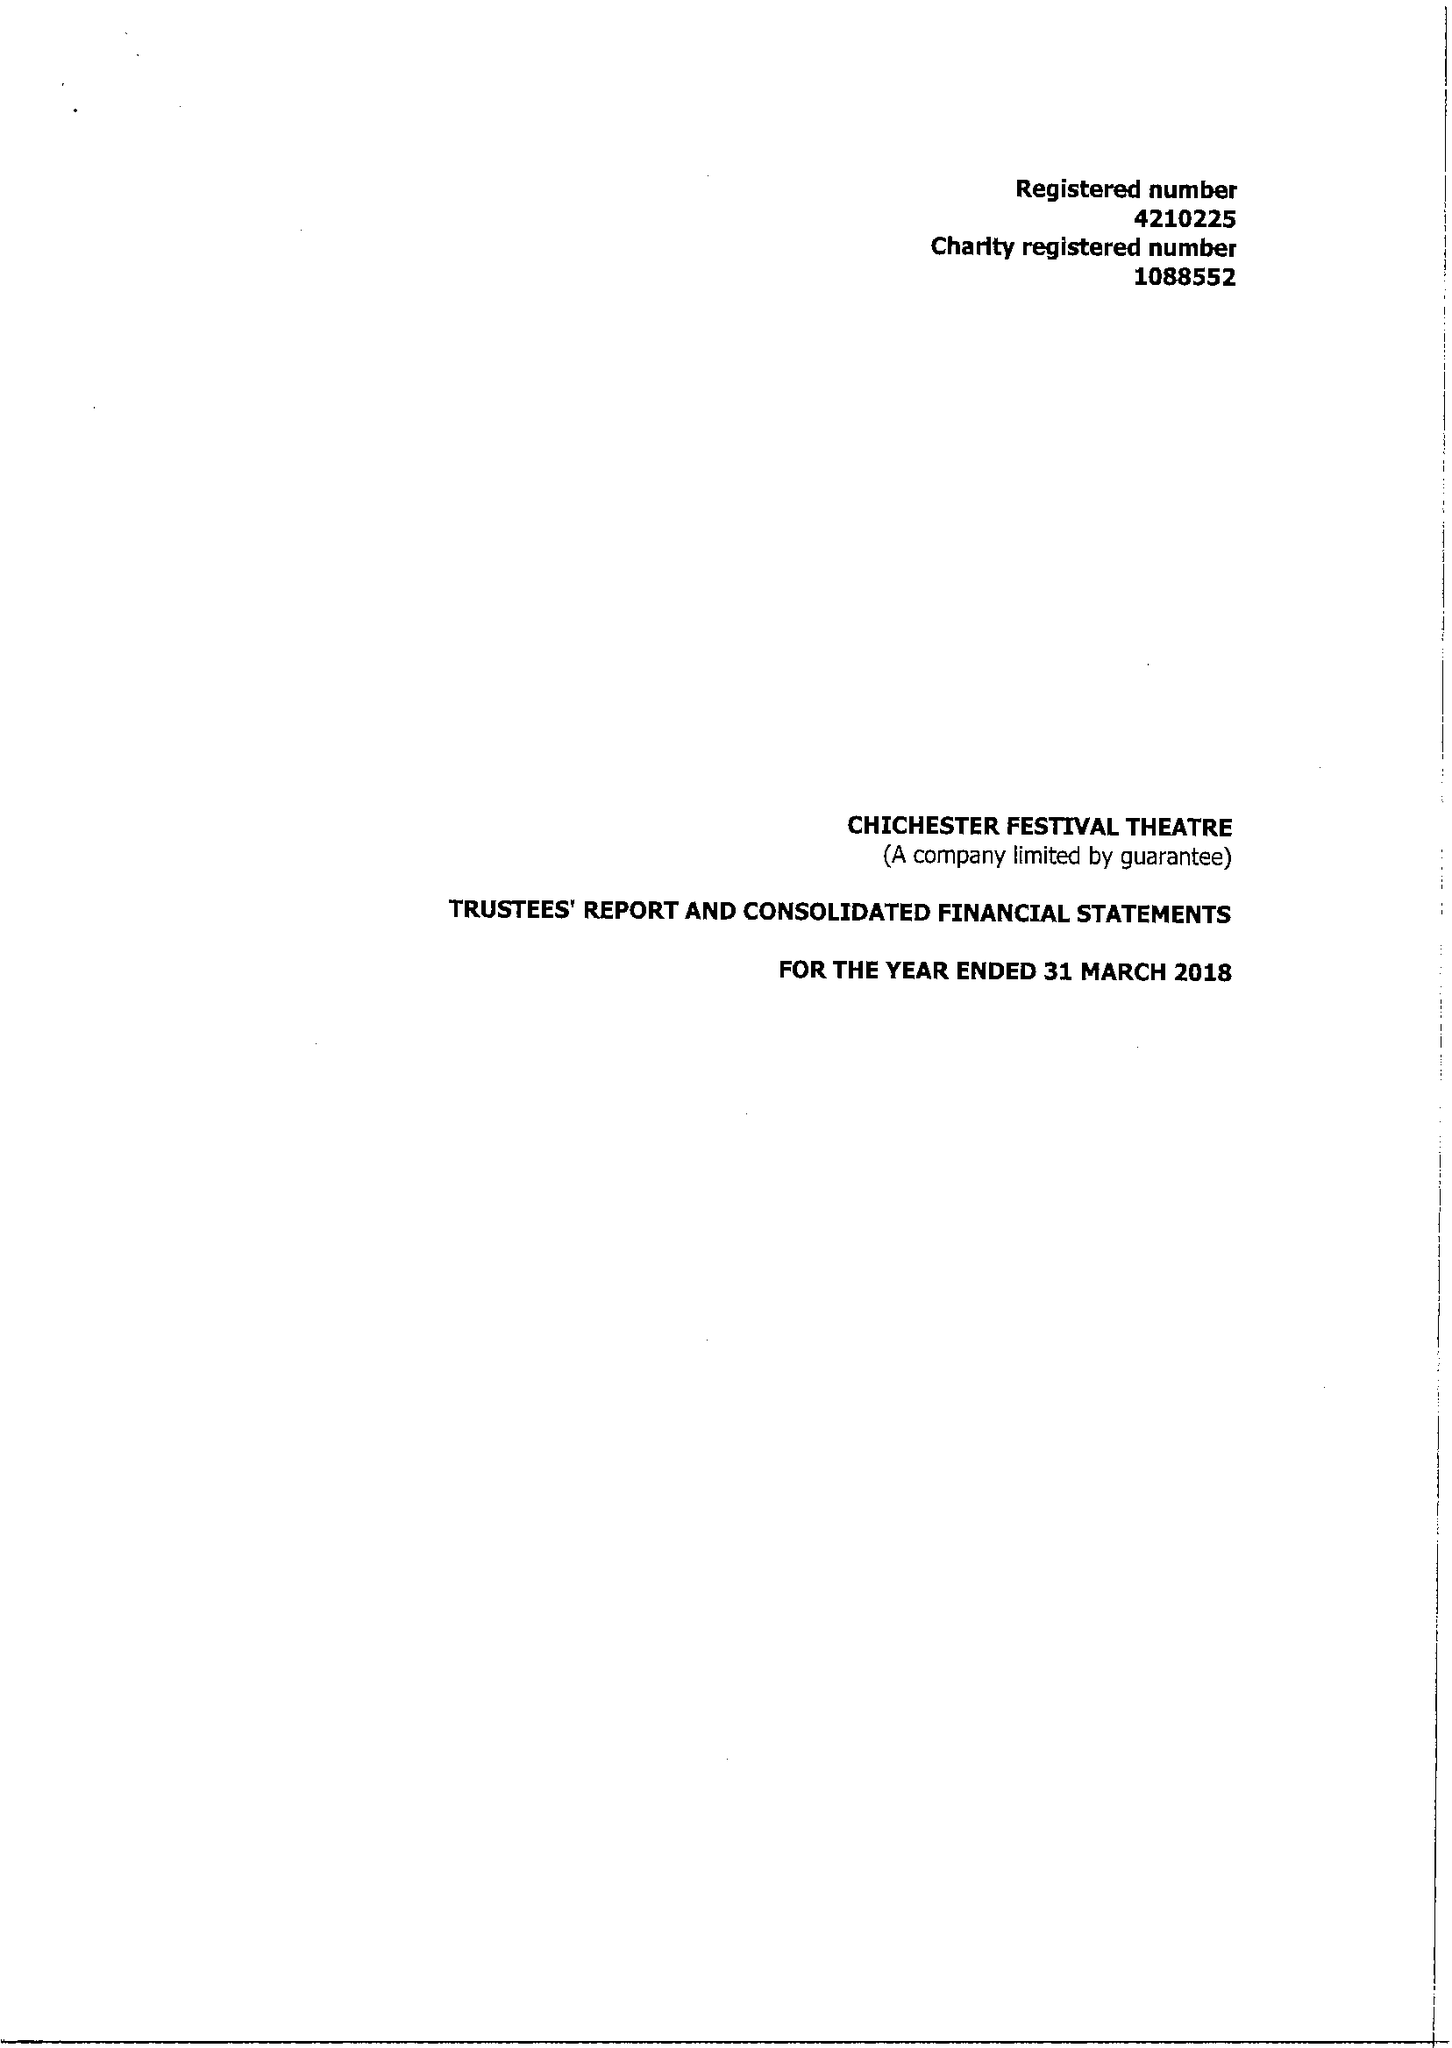What is the value for the address__street_line?
Answer the question using a single word or phrase. OAKLANDS PARK 